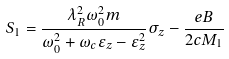<formula> <loc_0><loc_0><loc_500><loc_500>S _ { 1 } = \frac { \lambda _ { R } ^ { 2 } \omega _ { 0 } ^ { 2 } m } { \omega _ { 0 } ^ { 2 } + \omega _ { c } \varepsilon _ { z } - \varepsilon _ { z } ^ { 2 } } \sigma _ { z } - \frac { e B } { 2 c M _ { 1 } }</formula> 